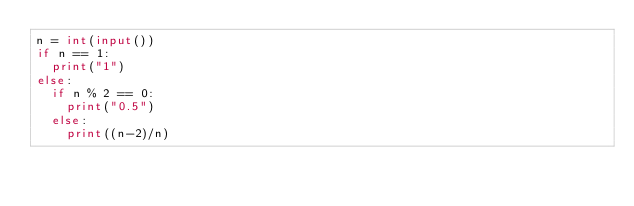Convert code to text. <code><loc_0><loc_0><loc_500><loc_500><_Python_>n = int(input())
if n == 1:
  print("1")
else:
  if n % 2 == 0:
    print("0.5")
  else:
    print((n-2)/n)</code> 